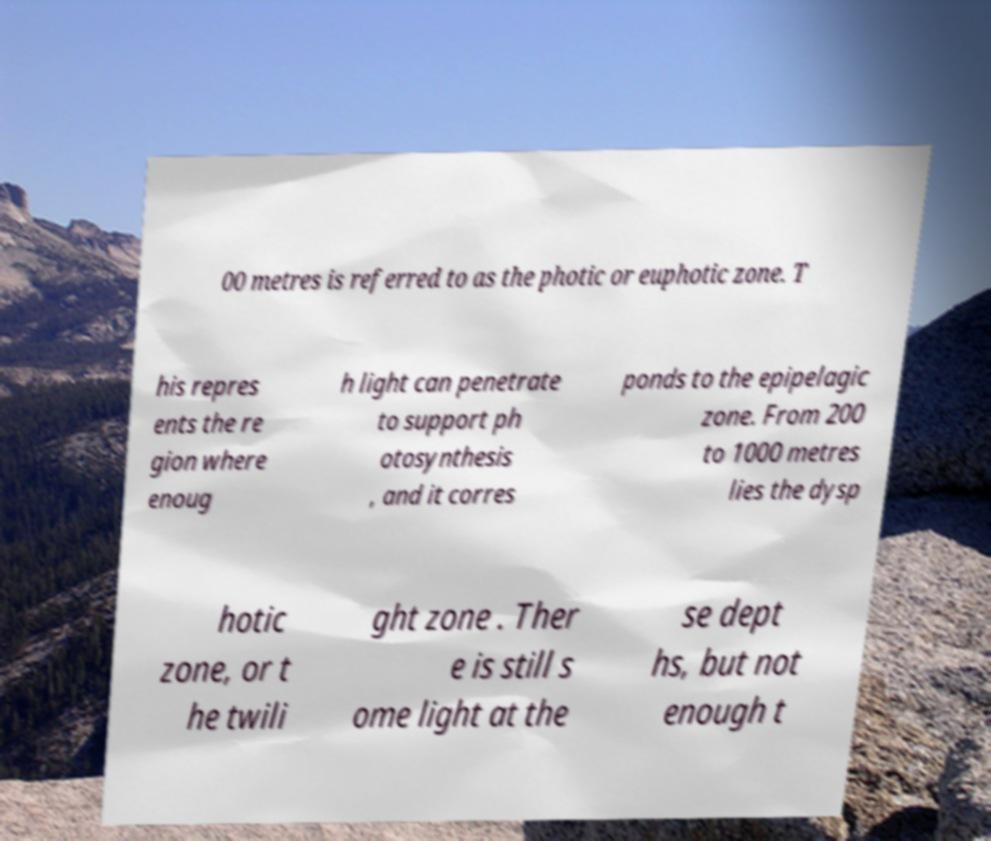Please identify and transcribe the text found in this image. 00 metres is referred to as the photic or euphotic zone. T his repres ents the re gion where enoug h light can penetrate to support ph otosynthesis , and it corres ponds to the epipelagic zone. From 200 to 1000 metres lies the dysp hotic zone, or t he twili ght zone . Ther e is still s ome light at the se dept hs, but not enough t 